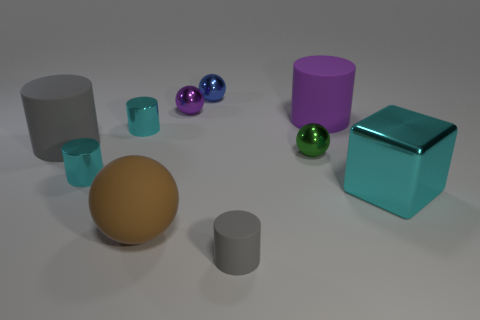Subtract 1 cylinders. How many cylinders are left? 4 Subtract all purple matte cylinders. How many cylinders are left? 4 Subtract all purple cylinders. How many cylinders are left? 4 Subtract all yellow spheres. Subtract all cyan blocks. How many spheres are left? 4 Subtract 1 blue spheres. How many objects are left? 9 Subtract all cubes. How many objects are left? 9 Subtract all cyan metal cylinders. Subtract all shiny cubes. How many objects are left? 7 Add 2 shiny cubes. How many shiny cubes are left? 3 Add 6 cyan cylinders. How many cyan cylinders exist? 8 